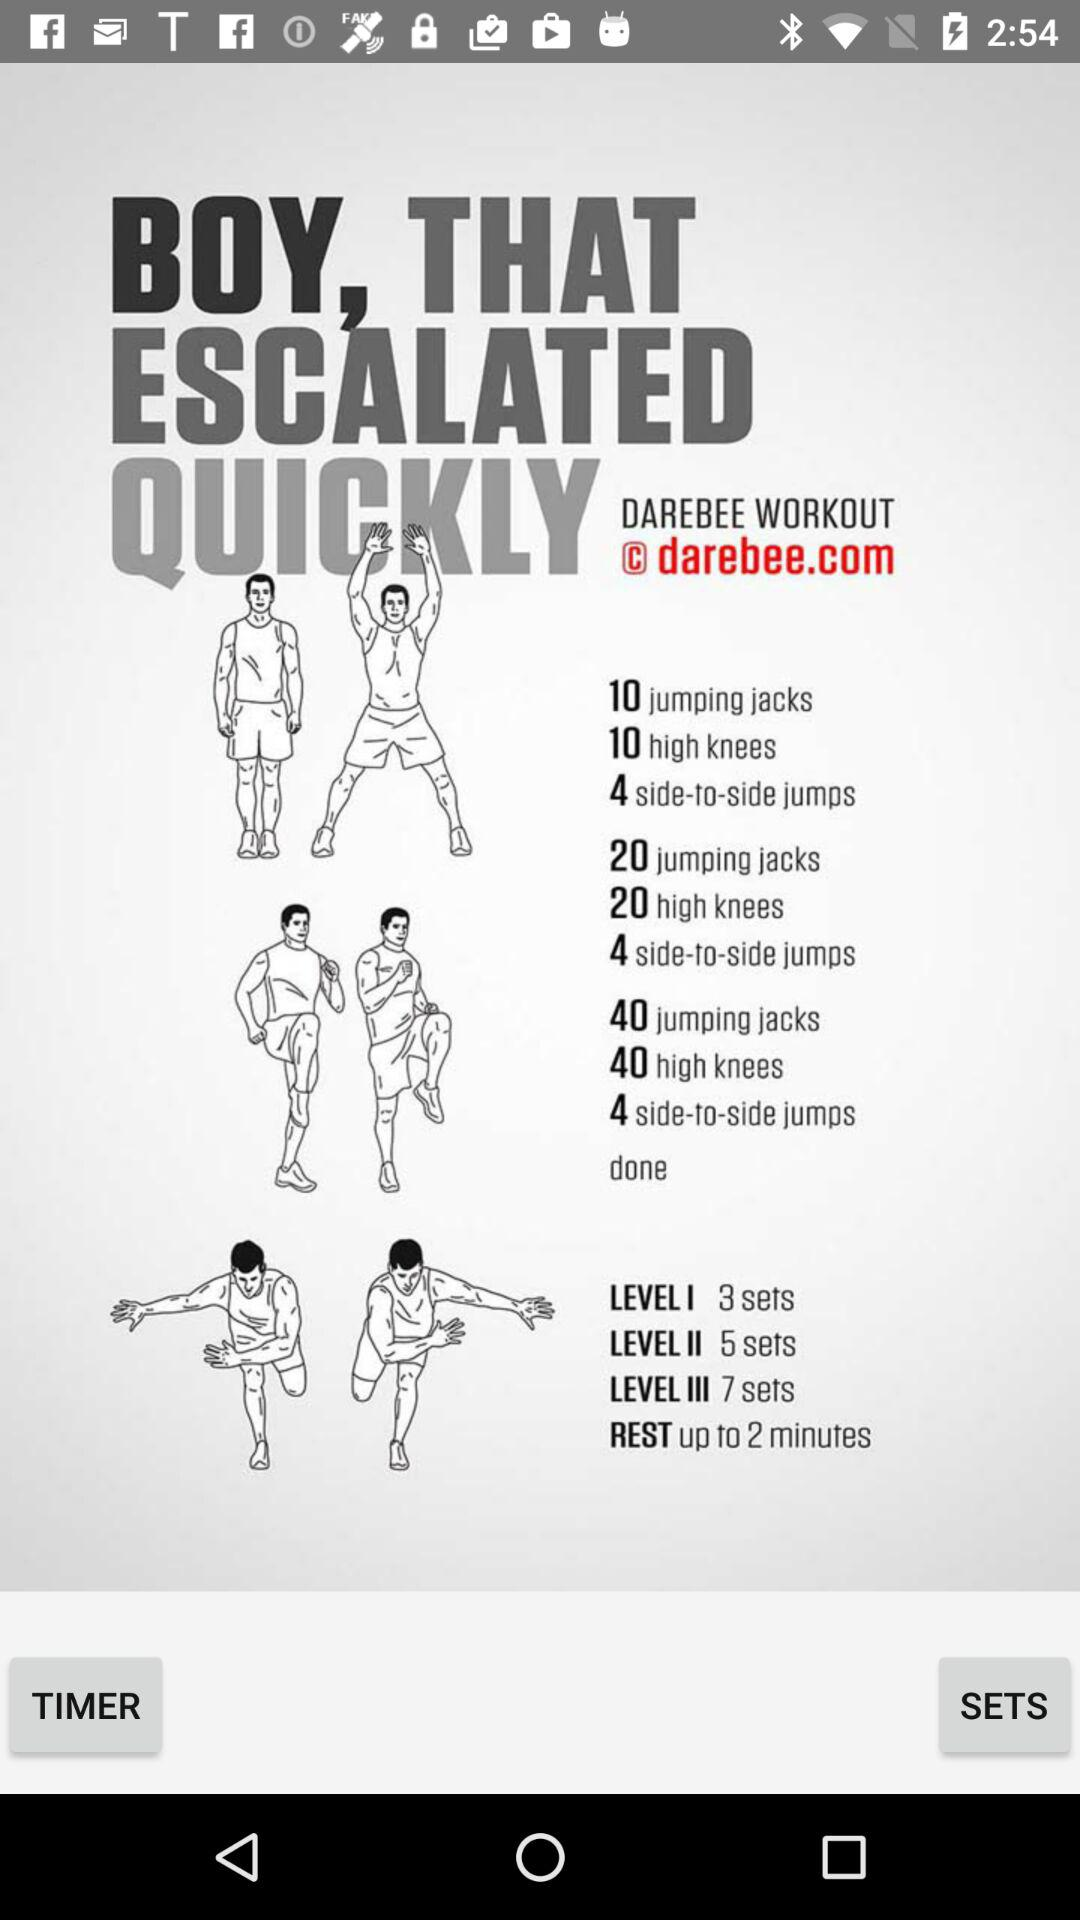How many total jumping jacks are there in level I?
Answer the question using a single word or phrase. 30 